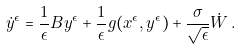<formula> <loc_0><loc_0><loc_500><loc_500>\dot { y } ^ { \epsilon } = \frac { 1 } { \epsilon } B y ^ { \epsilon } + \frac { 1 } { \epsilon } g ( x ^ { \epsilon } , y ^ { \epsilon } ) + \frac { \sigma } { \sqrt { \epsilon } } \dot { W } \, .</formula> 